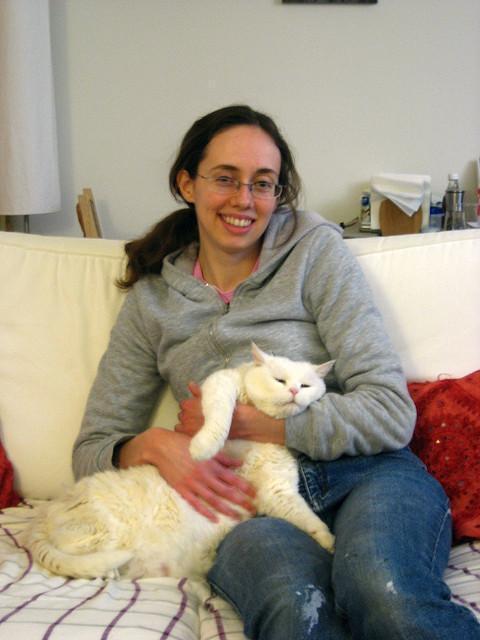Is this affirmation: "The couch is behind the person." correct?
Answer yes or no. No. 